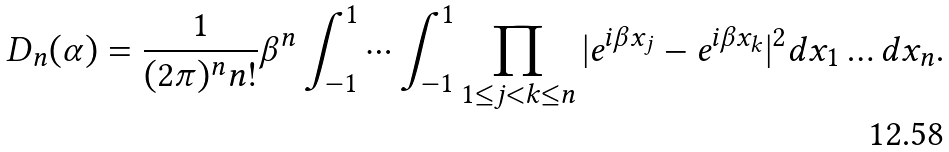Convert formula to latex. <formula><loc_0><loc_0><loc_500><loc_500>D _ { n } ( \alpha ) = \frac { 1 } { ( 2 \pi ) ^ { n } n ! } \beta ^ { n } \int _ { - 1 } ^ { 1 } \cdots \int _ { - 1 } ^ { 1 } \prod _ { 1 \leq j < k \leq n } | e ^ { i \beta x _ { j } } - e ^ { i \beta x _ { k } } | ^ { 2 } d x _ { 1 } \dots d x _ { n } .</formula> 